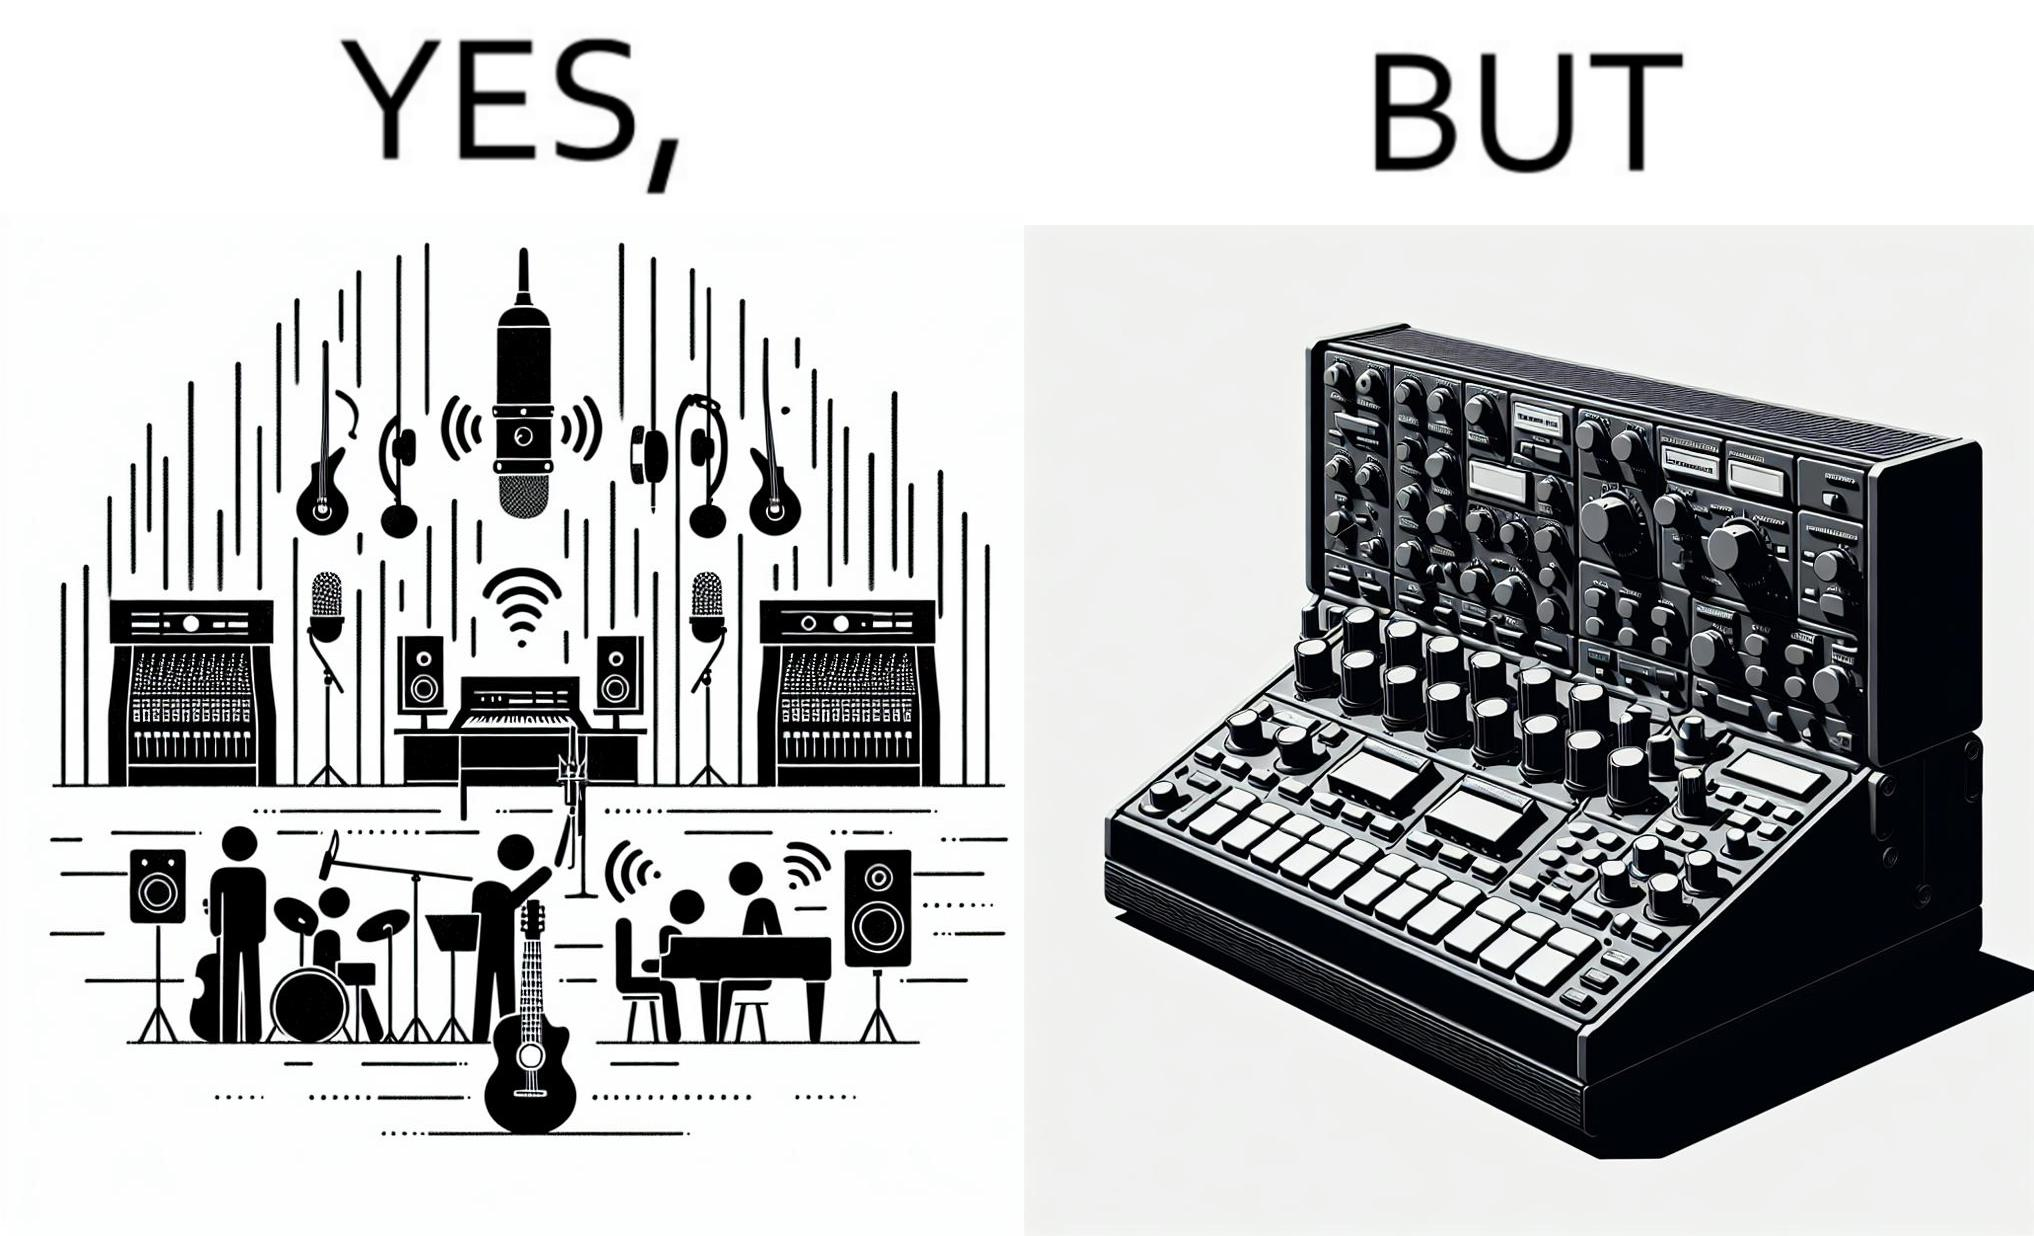Is this image satirical or non-satirical? Yes, this image is satirical. 